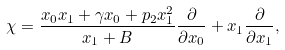<formula> <loc_0><loc_0><loc_500><loc_500>& \chi = \frac { x _ { 0 } x _ { 1 } + \gamma x _ { 0 } + p _ { 2 } x _ { 1 } ^ { 2 } } { x _ { 1 } + B } \frac { \partial } { \partial x _ { 0 } } + x _ { 1 } \frac { \partial } { \partial x _ { 1 } } ,</formula> 